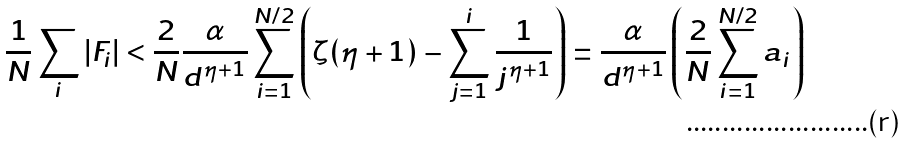<formula> <loc_0><loc_0><loc_500><loc_500>\frac { 1 } { N } \sum _ { i } | F _ { i } | < \frac { 2 } { N } \frac { \alpha } { d ^ { \eta + 1 } } \sum _ { i = 1 } ^ { N / 2 } \left ( \zeta ( \eta + 1 ) - \sum _ { j = 1 } ^ { i } \frac { 1 } { j ^ { \eta + 1 } } \right ) = \frac { \alpha } { d ^ { \eta + 1 } } \left ( \frac { 2 } { N } \sum _ { i = 1 } ^ { N / 2 } a _ { i } \right )</formula> 